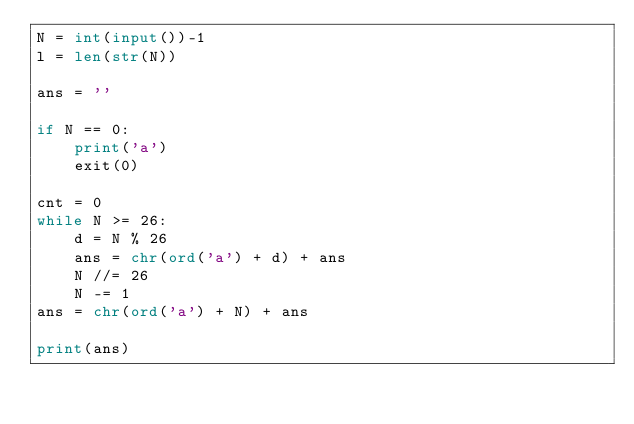Convert code to text. <code><loc_0><loc_0><loc_500><loc_500><_Python_>N = int(input())-1
l = len(str(N))

ans = ''

if N == 0:
    print('a')
    exit(0)

cnt = 0
while N >= 26:
    d = N % 26
    ans = chr(ord('a') + d) + ans
    N //= 26
    N -= 1
ans = chr(ord('a') + N) + ans

print(ans)
</code> 